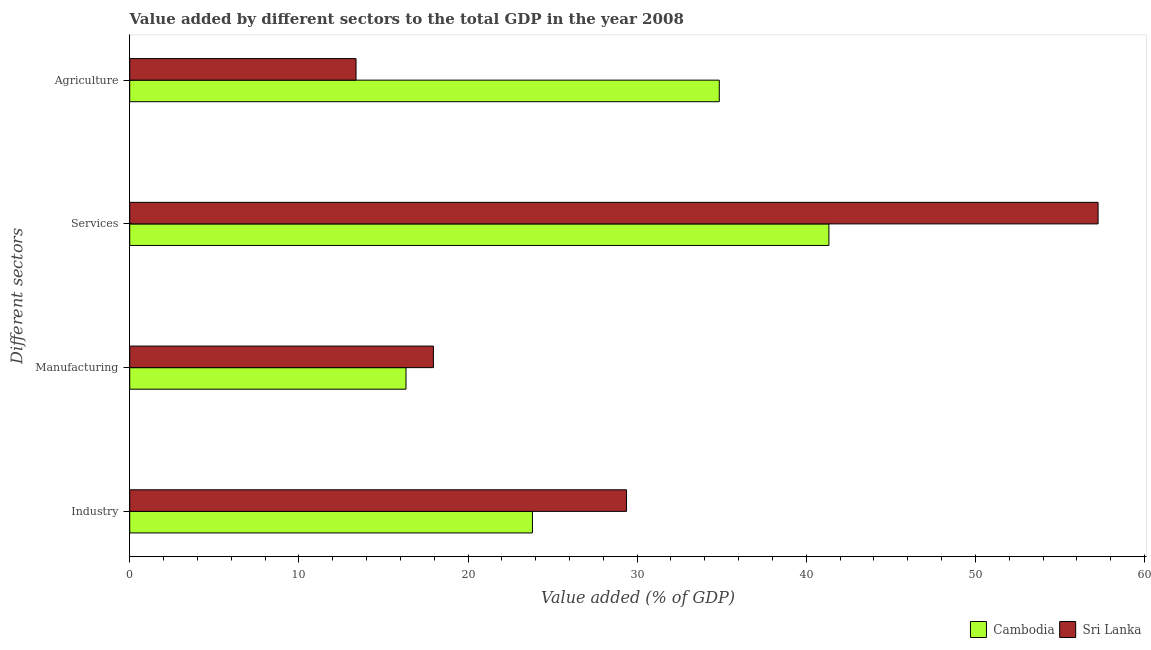How many groups of bars are there?
Your answer should be very brief. 4. Are the number of bars on each tick of the Y-axis equal?
Your answer should be very brief. Yes. How many bars are there on the 1st tick from the bottom?
Offer a very short reply. 2. What is the label of the 3rd group of bars from the top?
Your response must be concise. Manufacturing. What is the value added by industrial sector in Sri Lanka?
Give a very brief answer. 29.37. Across all countries, what is the maximum value added by services sector?
Your answer should be very brief. 57.25. Across all countries, what is the minimum value added by industrial sector?
Make the answer very short. 23.81. In which country was the value added by services sector maximum?
Offer a very short reply. Sri Lanka. In which country was the value added by industrial sector minimum?
Make the answer very short. Cambodia. What is the total value added by agricultural sector in the graph?
Your response must be concise. 48.23. What is the difference between the value added by industrial sector in Sri Lanka and that in Cambodia?
Your answer should be compact. 5.56. What is the difference between the value added by manufacturing sector in Cambodia and the value added by services sector in Sri Lanka?
Give a very brief answer. -40.92. What is the average value added by industrial sector per country?
Your answer should be very brief. 26.59. What is the difference between the value added by agricultural sector and value added by manufacturing sector in Cambodia?
Your answer should be compact. 18.52. What is the ratio of the value added by manufacturing sector in Cambodia to that in Sri Lanka?
Give a very brief answer. 0.91. What is the difference between the highest and the second highest value added by agricultural sector?
Make the answer very short. 21.48. What is the difference between the highest and the lowest value added by agricultural sector?
Keep it short and to the point. 21.48. In how many countries, is the value added by industrial sector greater than the average value added by industrial sector taken over all countries?
Make the answer very short. 1. Is the sum of the value added by manufacturing sector in Cambodia and Sri Lanka greater than the maximum value added by services sector across all countries?
Your response must be concise. No. Is it the case that in every country, the sum of the value added by industrial sector and value added by agricultural sector is greater than the sum of value added by manufacturing sector and value added by services sector?
Your answer should be very brief. No. What does the 1st bar from the top in Industry represents?
Your response must be concise. Sri Lanka. What does the 2nd bar from the bottom in Manufacturing represents?
Ensure brevity in your answer.  Sri Lanka. How many countries are there in the graph?
Offer a very short reply. 2. Where does the legend appear in the graph?
Your answer should be compact. Bottom right. How many legend labels are there?
Offer a very short reply. 2. How are the legend labels stacked?
Give a very brief answer. Horizontal. What is the title of the graph?
Give a very brief answer. Value added by different sectors to the total GDP in the year 2008. Does "Lebanon" appear as one of the legend labels in the graph?
Your answer should be very brief. No. What is the label or title of the X-axis?
Your answer should be very brief. Value added (% of GDP). What is the label or title of the Y-axis?
Your response must be concise. Different sectors. What is the Value added (% of GDP) in Cambodia in Industry?
Offer a very short reply. 23.81. What is the Value added (% of GDP) in Sri Lanka in Industry?
Your response must be concise. 29.37. What is the Value added (% of GDP) in Cambodia in Manufacturing?
Your response must be concise. 16.33. What is the Value added (% of GDP) in Sri Lanka in Manufacturing?
Your answer should be very brief. 17.95. What is the Value added (% of GDP) of Cambodia in Services?
Keep it short and to the point. 41.34. What is the Value added (% of GDP) in Sri Lanka in Services?
Ensure brevity in your answer.  57.25. What is the Value added (% of GDP) in Cambodia in Agriculture?
Offer a terse response. 34.85. What is the Value added (% of GDP) of Sri Lanka in Agriculture?
Your answer should be compact. 13.38. Across all Different sectors, what is the maximum Value added (% of GDP) in Cambodia?
Offer a terse response. 41.34. Across all Different sectors, what is the maximum Value added (% of GDP) of Sri Lanka?
Your answer should be very brief. 57.25. Across all Different sectors, what is the minimum Value added (% of GDP) of Cambodia?
Keep it short and to the point. 16.33. Across all Different sectors, what is the minimum Value added (% of GDP) in Sri Lanka?
Your answer should be very brief. 13.38. What is the total Value added (% of GDP) in Cambodia in the graph?
Offer a terse response. 116.33. What is the total Value added (% of GDP) of Sri Lanka in the graph?
Provide a short and direct response. 117.95. What is the difference between the Value added (% of GDP) in Cambodia in Industry and that in Manufacturing?
Your response must be concise. 7.48. What is the difference between the Value added (% of GDP) in Sri Lanka in Industry and that in Manufacturing?
Your answer should be compact. 11.42. What is the difference between the Value added (% of GDP) of Cambodia in Industry and that in Services?
Your answer should be compact. -17.53. What is the difference between the Value added (% of GDP) in Sri Lanka in Industry and that in Services?
Your answer should be compact. -27.88. What is the difference between the Value added (% of GDP) in Cambodia in Industry and that in Agriculture?
Keep it short and to the point. -11.05. What is the difference between the Value added (% of GDP) of Sri Lanka in Industry and that in Agriculture?
Ensure brevity in your answer.  15.99. What is the difference between the Value added (% of GDP) of Cambodia in Manufacturing and that in Services?
Give a very brief answer. -25. What is the difference between the Value added (% of GDP) in Sri Lanka in Manufacturing and that in Services?
Offer a very short reply. -39.3. What is the difference between the Value added (% of GDP) in Cambodia in Manufacturing and that in Agriculture?
Your answer should be very brief. -18.52. What is the difference between the Value added (% of GDP) in Sri Lanka in Manufacturing and that in Agriculture?
Give a very brief answer. 4.57. What is the difference between the Value added (% of GDP) in Cambodia in Services and that in Agriculture?
Keep it short and to the point. 6.48. What is the difference between the Value added (% of GDP) of Sri Lanka in Services and that in Agriculture?
Provide a succinct answer. 43.87. What is the difference between the Value added (% of GDP) in Cambodia in Industry and the Value added (% of GDP) in Sri Lanka in Manufacturing?
Keep it short and to the point. 5.85. What is the difference between the Value added (% of GDP) of Cambodia in Industry and the Value added (% of GDP) of Sri Lanka in Services?
Your response must be concise. -33.44. What is the difference between the Value added (% of GDP) of Cambodia in Industry and the Value added (% of GDP) of Sri Lanka in Agriculture?
Provide a succinct answer. 10.43. What is the difference between the Value added (% of GDP) of Cambodia in Manufacturing and the Value added (% of GDP) of Sri Lanka in Services?
Make the answer very short. -40.92. What is the difference between the Value added (% of GDP) of Cambodia in Manufacturing and the Value added (% of GDP) of Sri Lanka in Agriculture?
Ensure brevity in your answer.  2.95. What is the difference between the Value added (% of GDP) in Cambodia in Services and the Value added (% of GDP) in Sri Lanka in Agriculture?
Your answer should be compact. 27.96. What is the average Value added (% of GDP) in Cambodia per Different sectors?
Provide a short and direct response. 29.08. What is the average Value added (% of GDP) in Sri Lanka per Different sectors?
Your answer should be compact. 29.49. What is the difference between the Value added (% of GDP) of Cambodia and Value added (% of GDP) of Sri Lanka in Industry?
Keep it short and to the point. -5.56. What is the difference between the Value added (% of GDP) in Cambodia and Value added (% of GDP) in Sri Lanka in Manufacturing?
Ensure brevity in your answer.  -1.62. What is the difference between the Value added (% of GDP) of Cambodia and Value added (% of GDP) of Sri Lanka in Services?
Offer a very short reply. -15.91. What is the difference between the Value added (% of GDP) in Cambodia and Value added (% of GDP) in Sri Lanka in Agriculture?
Offer a terse response. 21.48. What is the ratio of the Value added (% of GDP) in Cambodia in Industry to that in Manufacturing?
Your answer should be very brief. 1.46. What is the ratio of the Value added (% of GDP) of Sri Lanka in Industry to that in Manufacturing?
Provide a short and direct response. 1.64. What is the ratio of the Value added (% of GDP) in Cambodia in Industry to that in Services?
Offer a very short reply. 0.58. What is the ratio of the Value added (% of GDP) of Sri Lanka in Industry to that in Services?
Keep it short and to the point. 0.51. What is the ratio of the Value added (% of GDP) in Cambodia in Industry to that in Agriculture?
Keep it short and to the point. 0.68. What is the ratio of the Value added (% of GDP) in Sri Lanka in Industry to that in Agriculture?
Your answer should be compact. 2.2. What is the ratio of the Value added (% of GDP) in Cambodia in Manufacturing to that in Services?
Your answer should be compact. 0.4. What is the ratio of the Value added (% of GDP) of Sri Lanka in Manufacturing to that in Services?
Your response must be concise. 0.31. What is the ratio of the Value added (% of GDP) of Cambodia in Manufacturing to that in Agriculture?
Make the answer very short. 0.47. What is the ratio of the Value added (% of GDP) in Sri Lanka in Manufacturing to that in Agriculture?
Your answer should be very brief. 1.34. What is the ratio of the Value added (% of GDP) of Cambodia in Services to that in Agriculture?
Give a very brief answer. 1.19. What is the ratio of the Value added (% of GDP) of Sri Lanka in Services to that in Agriculture?
Your response must be concise. 4.28. What is the difference between the highest and the second highest Value added (% of GDP) of Cambodia?
Offer a terse response. 6.48. What is the difference between the highest and the second highest Value added (% of GDP) of Sri Lanka?
Keep it short and to the point. 27.88. What is the difference between the highest and the lowest Value added (% of GDP) in Cambodia?
Provide a short and direct response. 25. What is the difference between the highest and the lowest Value added (% of GDP) of Sri Lanka?
Provide a succinct answer. 43.87. 